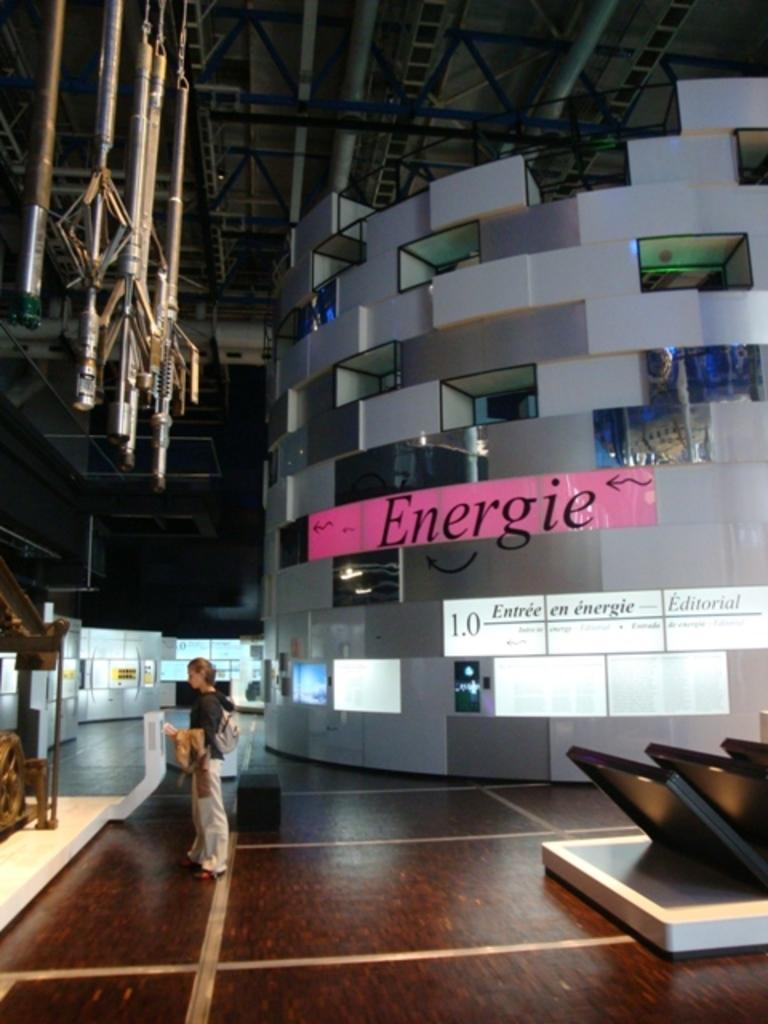<image>
Relay a brief, clear account of the picture shown. An oddly shaped wall with Energie written in black. 